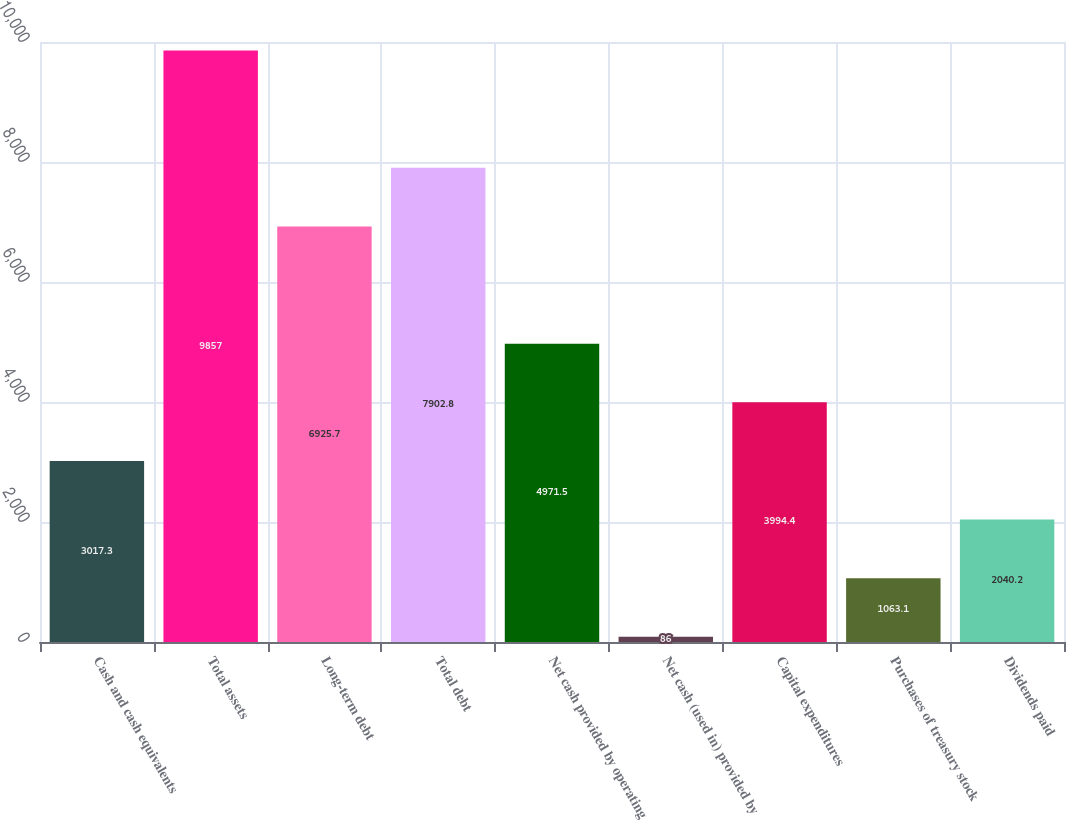<chart> <loc_0><loc_0><loc_500><loc_500><bar_chart><fcel>Cash and cash equivalents<fcel>Total assets<fcel>Long-term debt<fcel>Total debt<fcel>Net cash provided by operating<fcel>Net cash (used in) provided by<fcel>Capital expenditures<fcel>Purchases of treasury stock<fcel>Dividends paid<nl><fcel>3017.3<fcel>9857<fcel>6925.7<fcel>7902.8<fcel>4971.5<fcel>86<fcel>3994.4<fcel>1063.1<fcel>2040.2<nl></chart> 